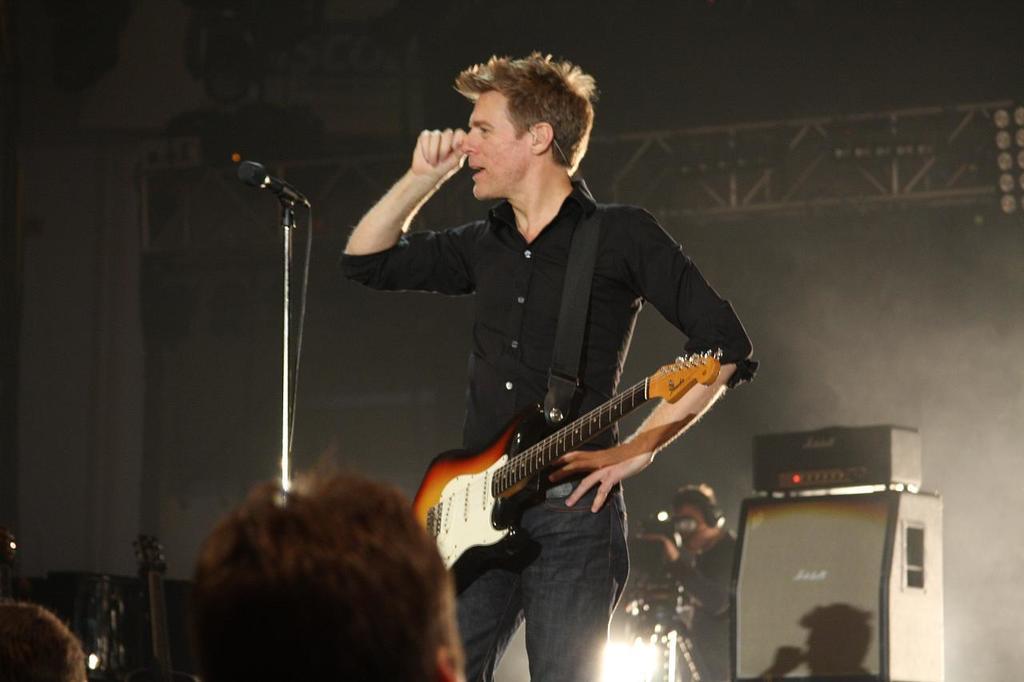How would you summarize this image in a sentence or two? In this image I see a man who is standing and carrying a guitar and there is a mic over here and I see persons head over here. In the background I see an equipment and a person with the camera and I see the light. 